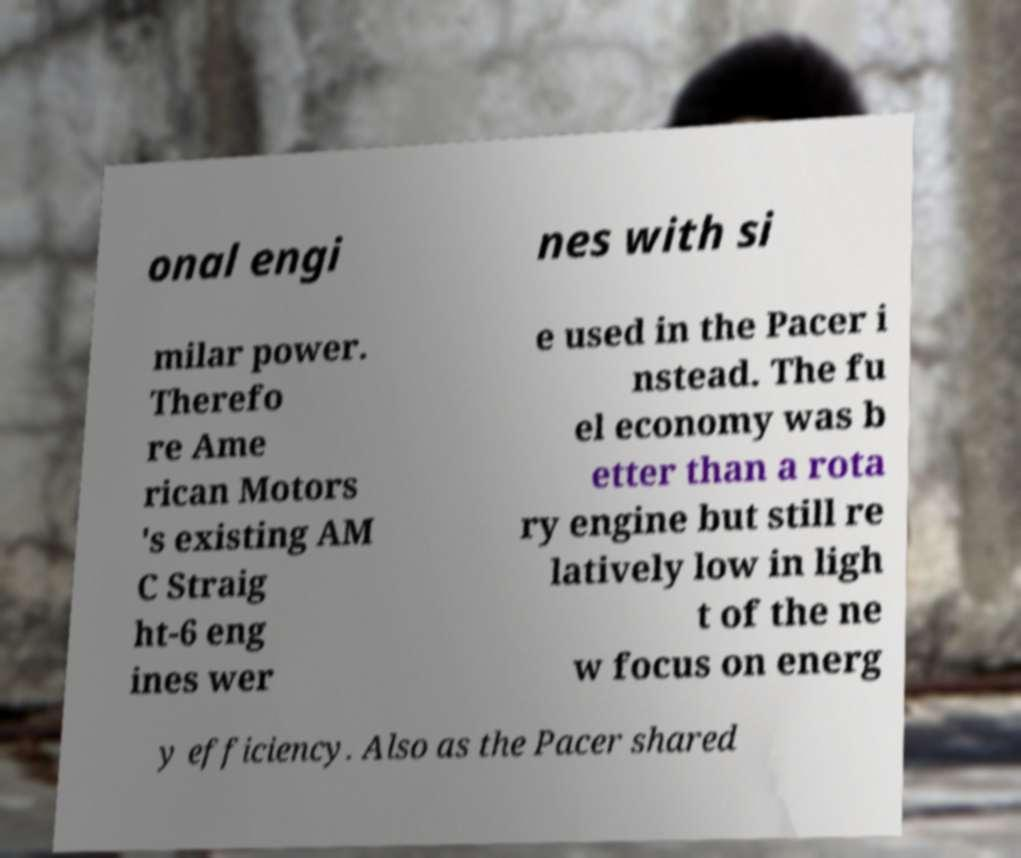Could you extract and type out the text from this image? onal engi nes with si milar power. Therefo re Ame rican Motors 's existing AM C Straig ht-6 eng ines wer e used in the Pacer i nstead. The fu el economy was b etter than a rota ry engine but still re latively low in ligh t of the ne w focus on energ y efficiency. Also as the Pacer shared 